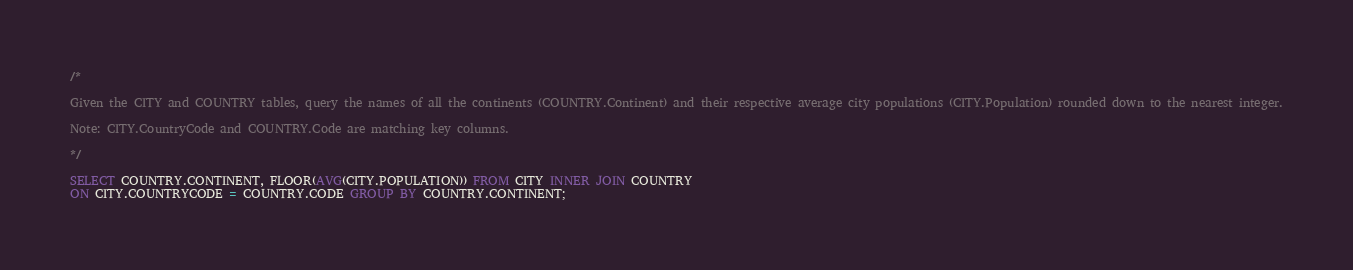<code> <loc_0><loc_0><loc_500><loc_500><_SQL_>/*

Given the CITY and COUNTRY tables, query the names of all the continents (COUNTRY.Continent) and their respective average city populations (CITY.Population) rounded down to the nearest integer.

Note: CITY.CountryCode and COUNTRY.Code are matching key columns.

*/

SELECT COUNTRY.CONTINENT, FLOOR(AVG(CITY.POPULATION)) FROM CITY INNER JOIN COUNTRY
ON CITY.COUNTRYCODE = COUNTRY.CODE GROUP BY COUNTRY.CONTINENT;</code> 